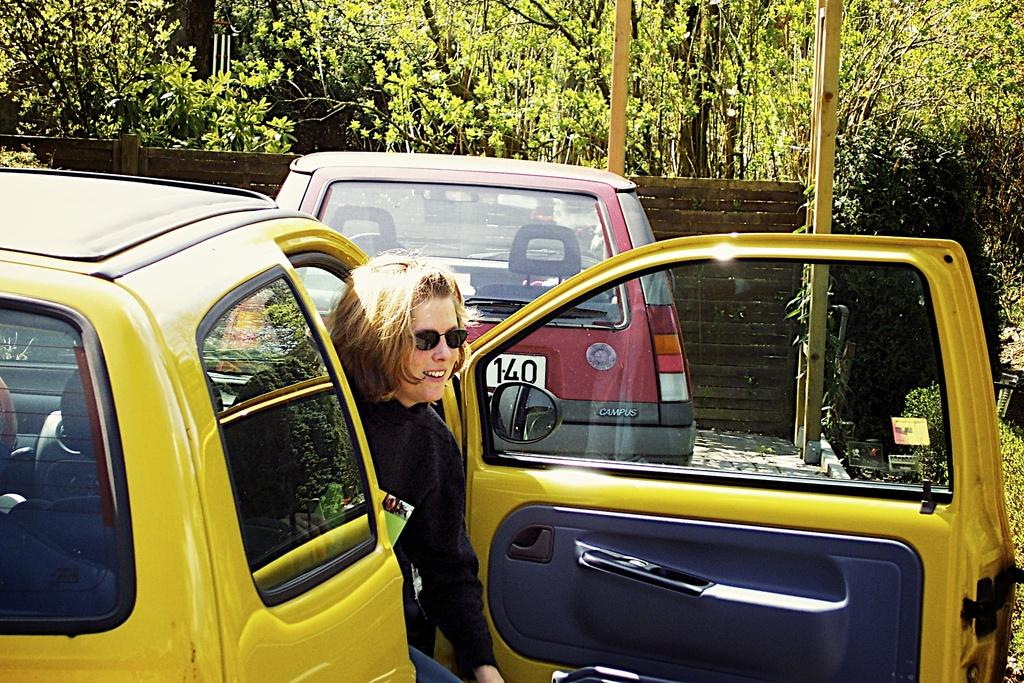<image>
Relay a brief, clear account of the picture shown. A woman getting out of a car behind another car with 140 on the license plate. 